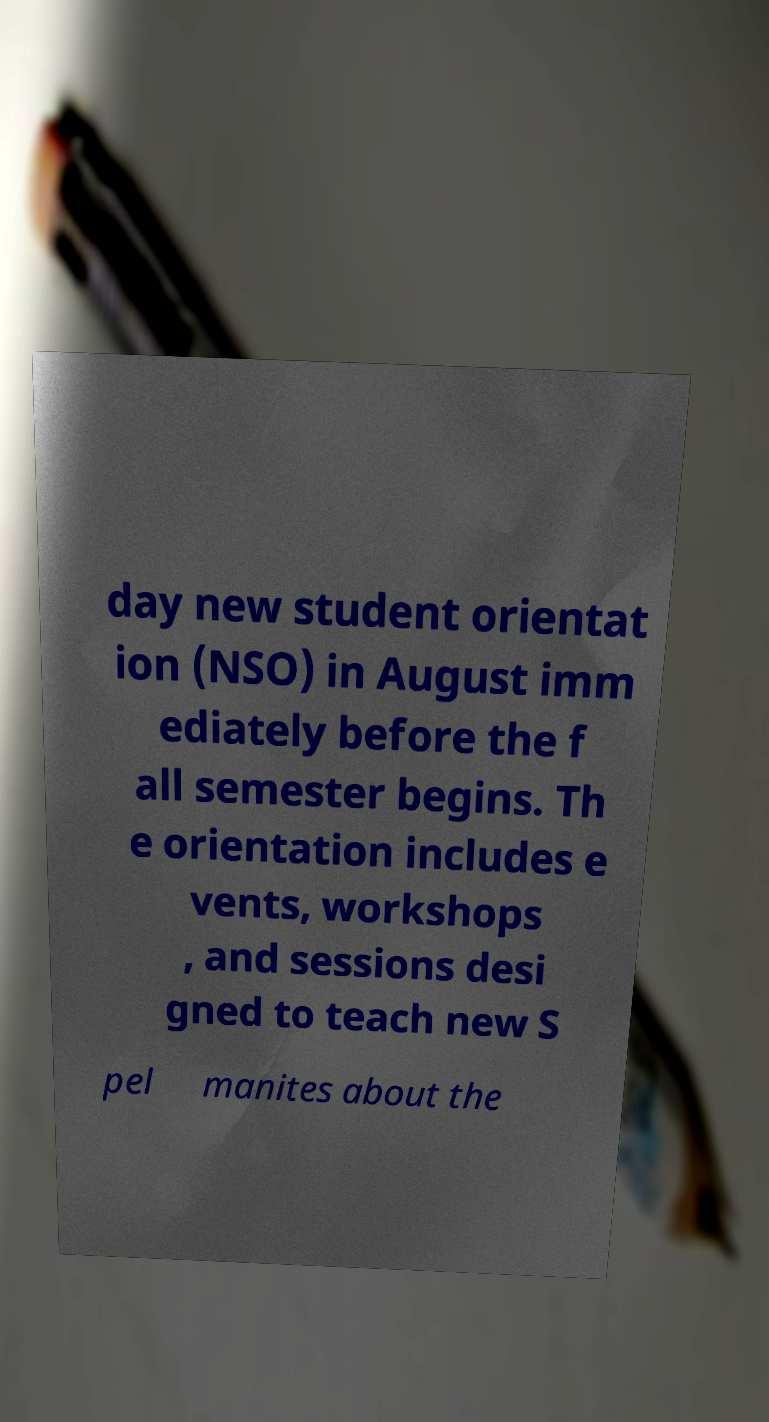I need the written content from this picture converted into text. Can you do that? day new student orientat ion (NSO) in August imm ediately before the f all semester begins. Th e orientation includes e vents, workshops , and sessions desi gned to teach new S pel manites about the 